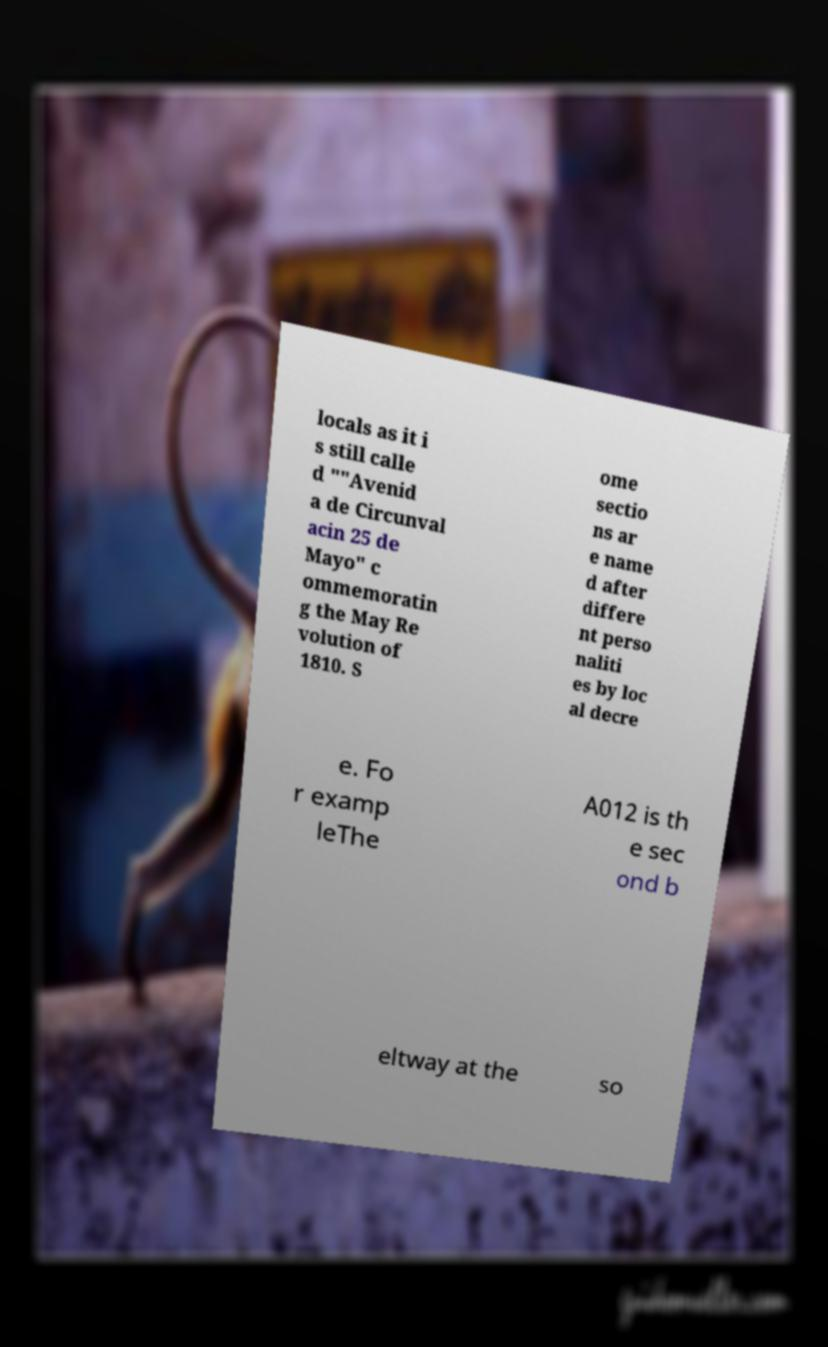Please identify and transcribe the text found in this image. locals as it i s still calle d ""Avenid a de Circunval acin 25 de Mayo" c ommemoratin g the May Re volution of 1810. S ome sectio ns ar e name d after differe nt perso naliti es by loc al decre e. Fo r examp leThe A012 is th e sec ond b eltway at the so 